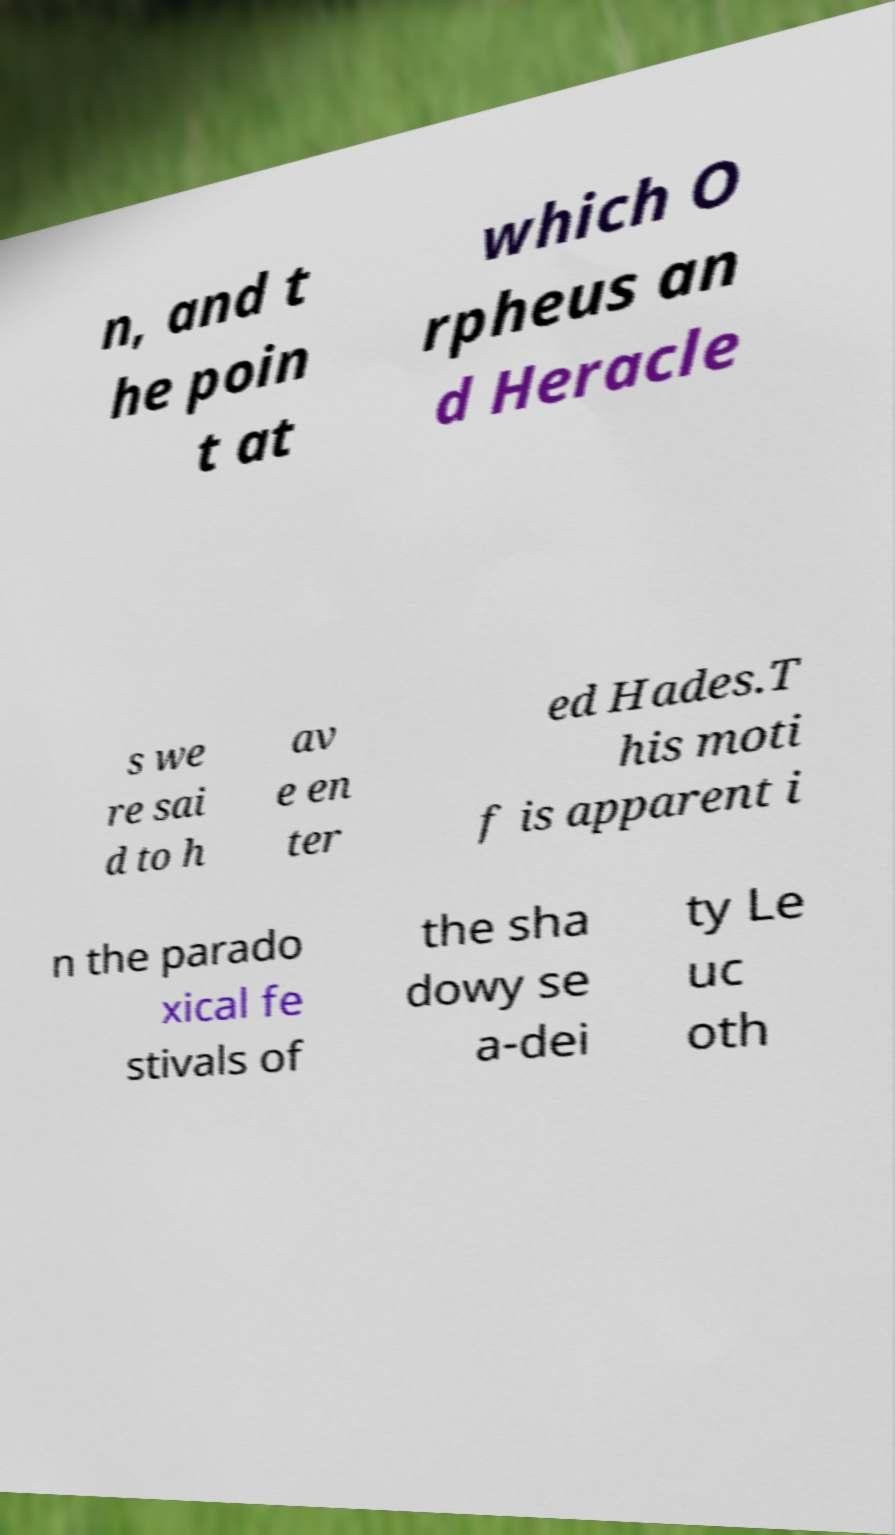What messages or text are displayed in this image? I need them in a readable, typed format. n, and t he poin t at which O rpheus an d Heracle s we re sai d to h av e en ter ed Hades.T his moti f is apparent i n the parado xical fe stivals of the sha dowy se a-dei ty Le uc oth 